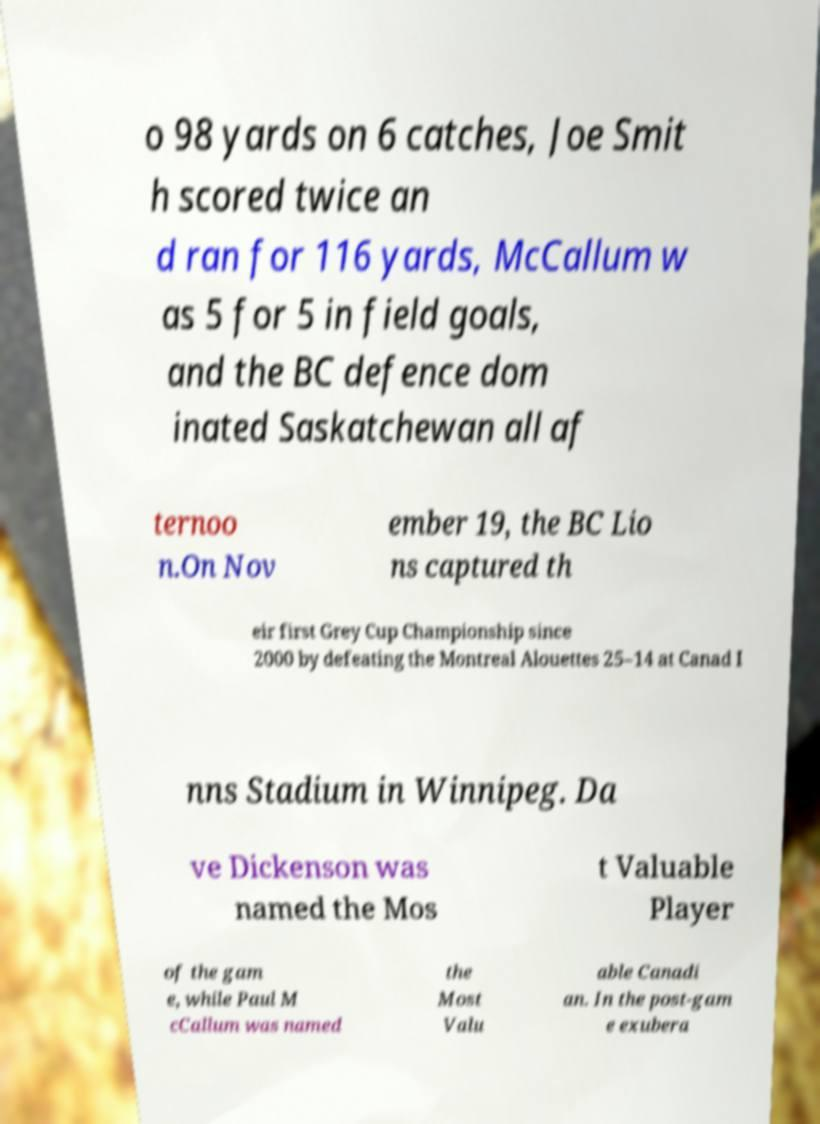For documentation purposes, I need the text within this image transcribed. Could you provide that? o 98 yards on 6 catches, Joe Smit h scored twice an d ran for 116 yards, McCallum w as 5 for 5 in field goals, and the BC defence dom inated Saskatchewan all af ternoo n.On Nov ember 19, the BC Lio ns captured th eir first Grey Cup Championship since 2000 by defeating the Montreal Alouettes 25–14 at Canad I nns Stadium in Winnipeg. Da ve Dickenson was named the Mos t Valuable Player of the gam e, while Paul M cCallum was named the Most Valu able Canadi an. In the post-gam e exubera 